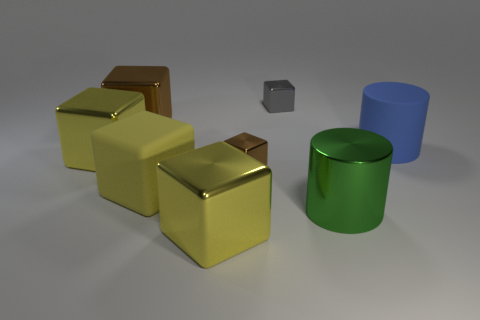There is another matte object that is the same shape as the big green object; what is its color?
Provide a short and direct response. Blue. Is there any other thing that is the same shape as the blue object?
Your response must be concise. Yes. The other tiny cube that is the same material as the small brown cube is what color?
Keep it short and to the point. Gray. There is a rubber thing that is on the left side of the yellow metallic thing in front of the metal cylinder; are there any big green metallic cylinders behind it?
Offer a very short reply. No. Are there fewer yellow things on the right side of the rubber cube than gray cubes that are in front of the blue rubber thing?
Offer a terse response. No. How many brown things have the same material as the green thing?
Your response must be concise. 2. Is the size of the shiny cylinder the same as the cylinder that is to the right of the large metallic cylinder?
Provide a succinct answer. Yes. How big is the cylinder that is in front of the small block in front of the big metallic cube that is behind the matte cylinder?
Your response must be concise. Large. Is the number of big blue rubber things that are left of the big brown block greater than the number of yellow rubber objects behind the big blue cylinder?
Your answer should be compact. No. There is a yellow metal block behind the tiny brown thing; what number of large brown blocks are in front of it?
Your answer should be very brief. 0. 